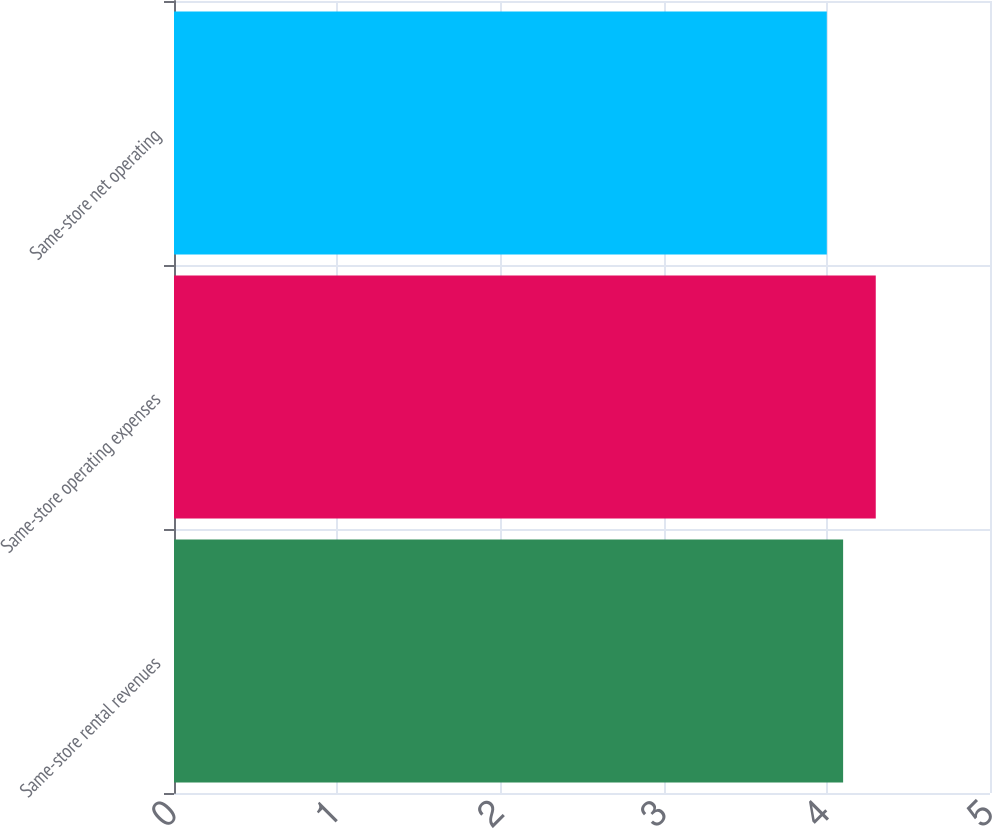Convert chart. <chart><loc_0><loc_0><loc_500><loc_500><bar_chart><fcel>Same-store rental revenues<fcel>Same-store operating expenses<fcel>Same-store net operating<nl><fcel>4.1<fcel>4.3<fcel>4<nl></chart> 